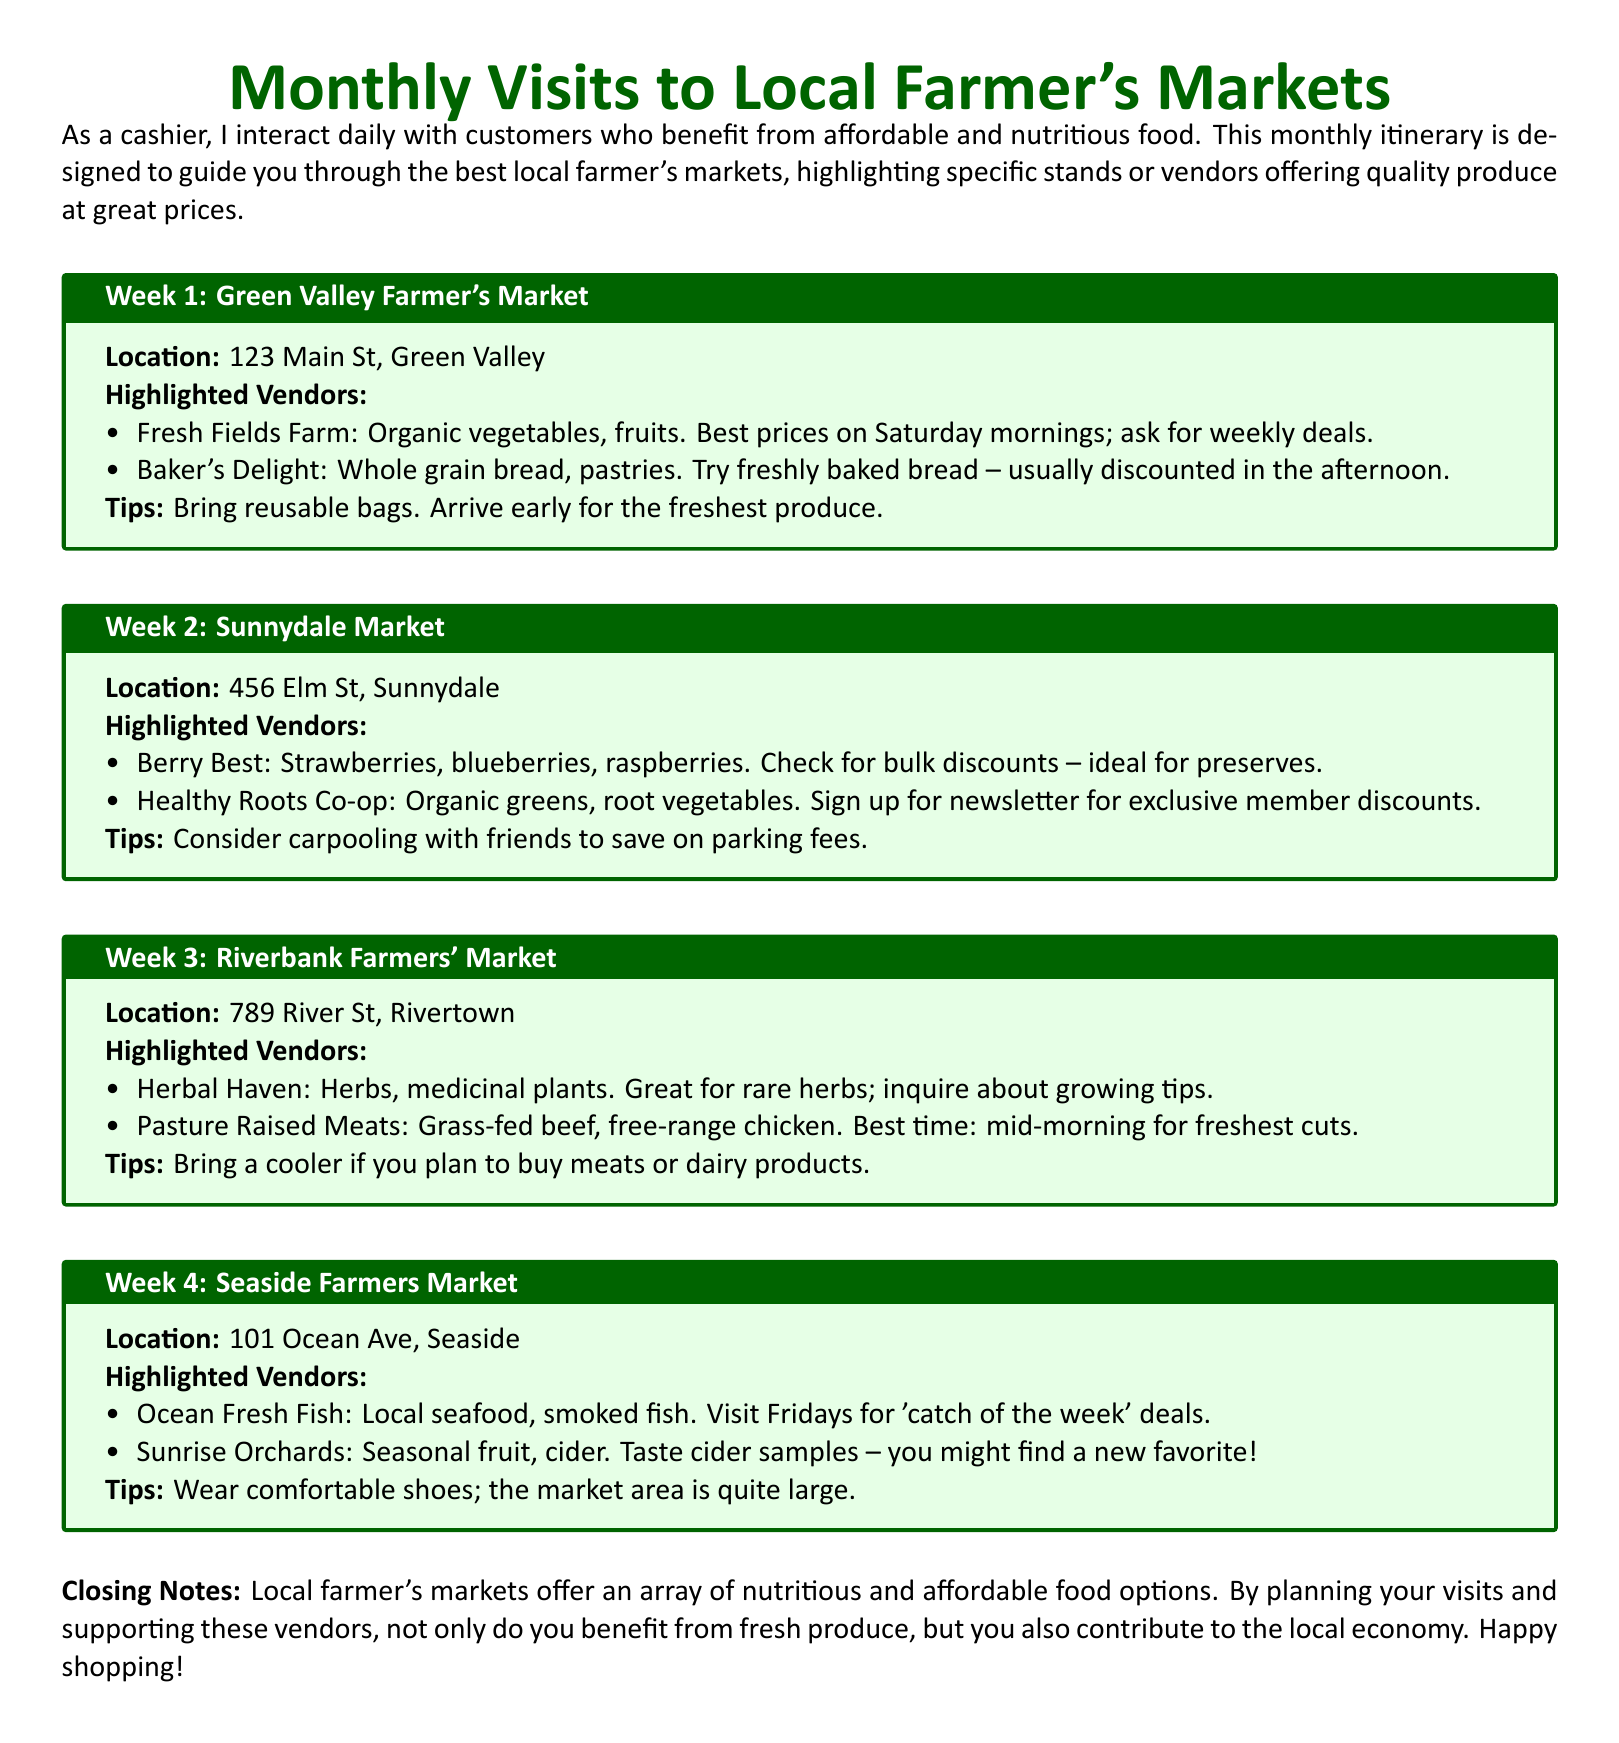What is the location of the Green Valley Farmer's Market? The location is listed in the document under the Green Valley Farmer's Market section, which is 123 Main St, Green Valley.
Answer: 123 Main St, Green Valley What is highlighted at Sunnydale Market for bulk discounts? The document states that "Berry Best" offers strawberries, blueberries, and raspberries with bulk discounts – ideal for preserves.
Answer: Strawberries, blueberries, raspberries What types of products does Pasture Raised Meats sell? The document mentions that Pasture Raised Meats sells grass-fed beef and free-range chicken.
Answer: Grass-fed beef, free-range chicken What day is the 'catch of the week' deal at Ocean Fresh Fish? The document specifies that these deals are available on Fridays.
Answer: Fridays How should you prepare if you plan to buy meats or dairy products? The document suggests bringing a cooler for purchasing meats or dairy products.
Answer: Bring a cooler What is a tip for saving on parking fees when visiting farmer's markets? The document recommends carpooling with friends to save on parking fees.
Answer: Carpooling Which week features Herbal Haven at the market? The third week of the itinerary mentions Herbal Haven as one of the highlighted vendors.
Answer: Week 3 What should you wear at the Seaside Farmers Market? The document advises wearing comfortable shoes because the market area is quite large.
Answer: Comfortable shoes How can you receive exclusive member discounts at Healthy Roots Co-op? The document states that signing up for the newsletter entitles you to exclusive member discounts.
Answer: Sign up for newsletter 